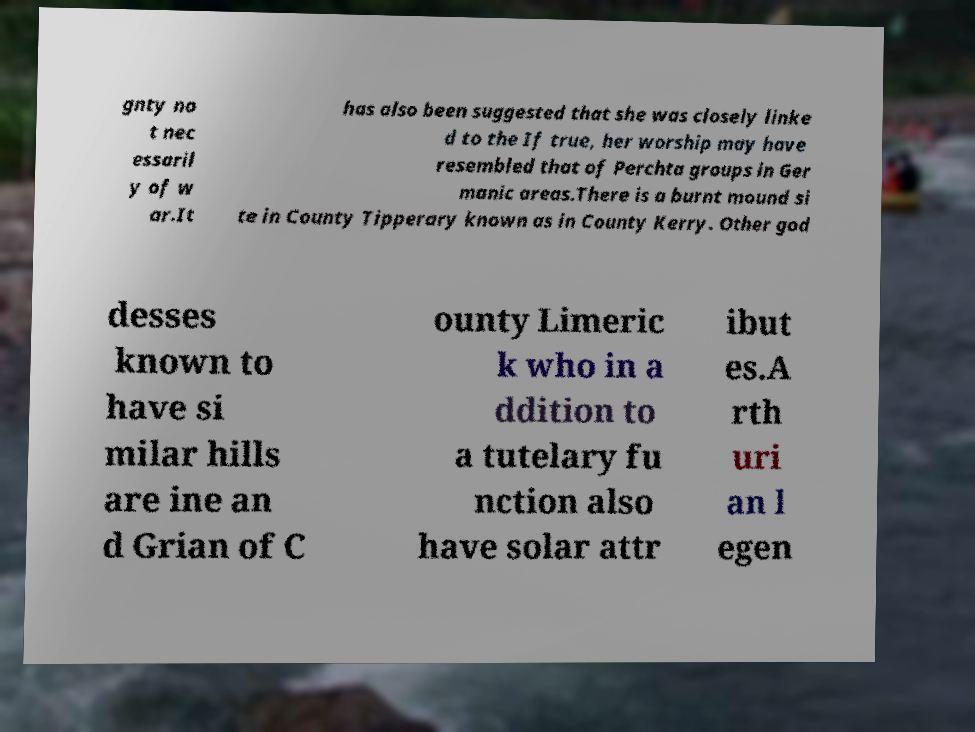What messages or text are displayed in this image? I need them in a readable, typed format. gnty no t nec essaril y of w ar.It has also been suggested that she was closely linke d to the If true, her worship may have resembled that of Perchta groups in Ger manic areas.There is a burnt mound si te in County Tipperary known as in County Kerry. Other god desses known to have si milar hills are ine an d Grian of C ounty Limeric k who in a ddition to a tutelary fu nction also have solar attr ibut es.A rth uri an l egen 